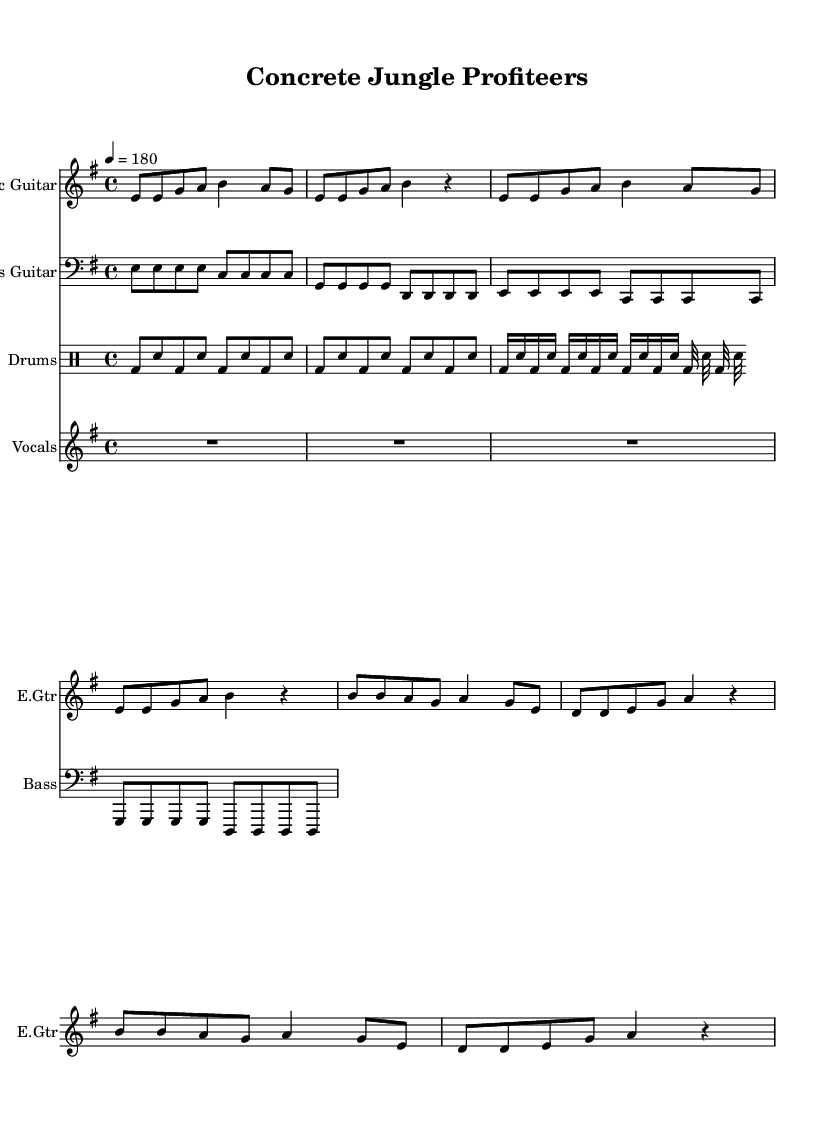What is the key signature of this music? The key signature is E minor, which has one sharp, F#, shown at the beginning of the staff.
Answer: E minor What is the time signature of this music? The time signature is 4/4, indicated by the "4" on top of another "4" at the beginning of the music.
Answer: 4/4 What is the tempo marking of this music? The tempo marking is 180 beats per minute, indicated with "4 = 180" under the tempo sign at the beginning.
Answer: 180 How many measures are in the verse section? The verse section contains 4 measures, as can be counted from the line of music that comprises the verses.
Answer: 4 What type of instrument is the 'vocals' part written for? The 'vocals' part is for voice, indicated by "Vocals" written at the beginning of that staff.
Answer: Voice Which instrument plays a continuous eighth note rhythm in the verse? The electric guitar plays a continuous eighth note rhythm, as shown in the notes during the verse measures.
Answer: Electric guitar What themes do the lyrics of this song suggest? The lyrics suggest themes of corporate greed and empty promises, as inferred from phrases like "Concrete rising" and "Empty promises."
Answer: Corporate greed 